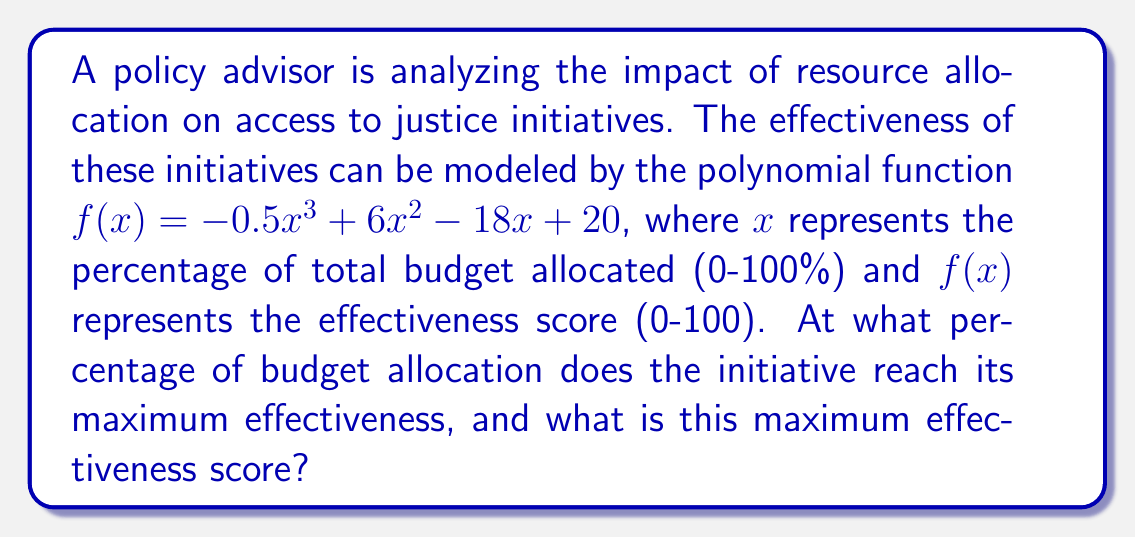Help me with this question. To find the maximum effectiveness and the corresponding budget allocation, we need to follow these steps:

1) First, we need to find the derivative of the function:
   $f'(x) = -1.5x^2 + 12x - 18$

2) Set the derivative equal to zero to find critical points:
   $-1.5x^2 + 12x - 18 = 0$

3) This is a quadratic equation. We can solve it using the quadratic formula:
   $x = \frac{-b \pm \sqrt{b^2 - 4ac}}{2a}$

   Where $a = -1.5$, $b = 12$, and $c = -18$

4) Plugging in these values:
   $x = \frac{-12 \pm \sqrt{12^2 - 4(-1.5)(-18)}}{2(-1.5)}$
   $= \frac{-12 \pm \sqrt{144 - 108}}{-3}$
   $= \frac{-12 \pm \sqrt{36}}{-3}$
   $= \frac{-12 \pm 6}{-3}$

5) This gives us two solutions:
   $x_1 = \frac{-12 + 6}{-3} = 2$
   $x_2 = \frac{-12 - 6}{-3} = 6$

6) To determine which of these gives the maximum, we can check the second derivative:
   $f''(x) = -3x + 12$

   At $x = 2$: $f''(2) = -3(2) + 12 = 6 > 0$, so this is a local minimum.
   At $x = 6$: $f''(6) = -3(6) + 12 = -6 < 0$, so this is a local maximum.

7) Therefore, the maximum occurs at $x = 6$, which represents 6% of the total budget.

8) To find the maximum effectiveness score, we plug $x = 6$ into the original function:
   $f(6) = -0.5(6)^3 + 6(6)^2 - 18(6) + 20$
   $= -108 + 216 - 108 + 20$
   $= 20$

Thus, the maximum effectiveness score is 20, occurring when 6% of the budget is allocated.
Answer: Maximum effectiveness of 20 at 6% budget allocation 